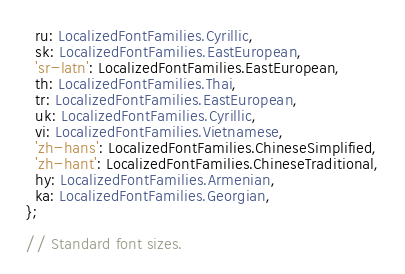Convert code to text. <code><loc_0><loc_0><loc_500><loc_500><_TypeScript_>  ru: LocalizedFontFamilies.Cyrillic,
  sk: LocalizedFontFamilies.EastEuropean,
  'sr-latn': LocalizedFontFamilies.EastEuropean,
  th: LocalizedFontFamilies.Thai,
  tr: LocalizedFontFamilies.EastEuropean,
  uk: LocalizedFontFamilies.Cyrillic,
  vi: LocalizedFontFamilies.Vietnamese,
  'zh-hans': LocalizedFontFamilies.ChineseSimplified,
  'zh-hant': LocalizedFontFamilies.ChineseTraditional,
  hy: LocalizedFontFamilies.Armenian,
  ka: LocalizedFontFamilies.Georgian,
};

// Standard font sizes.</code> 